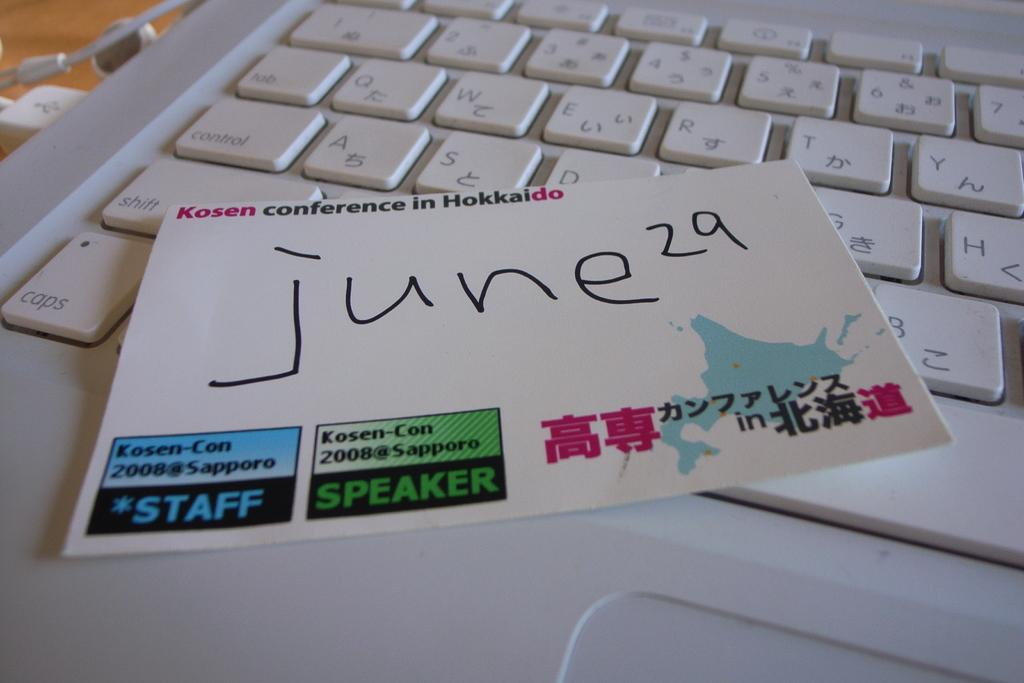<image>
Present a compact description of the photo's key features. A note from the 2008 Kosen Conference with a handwritten date on top of a laptop keyboard. 